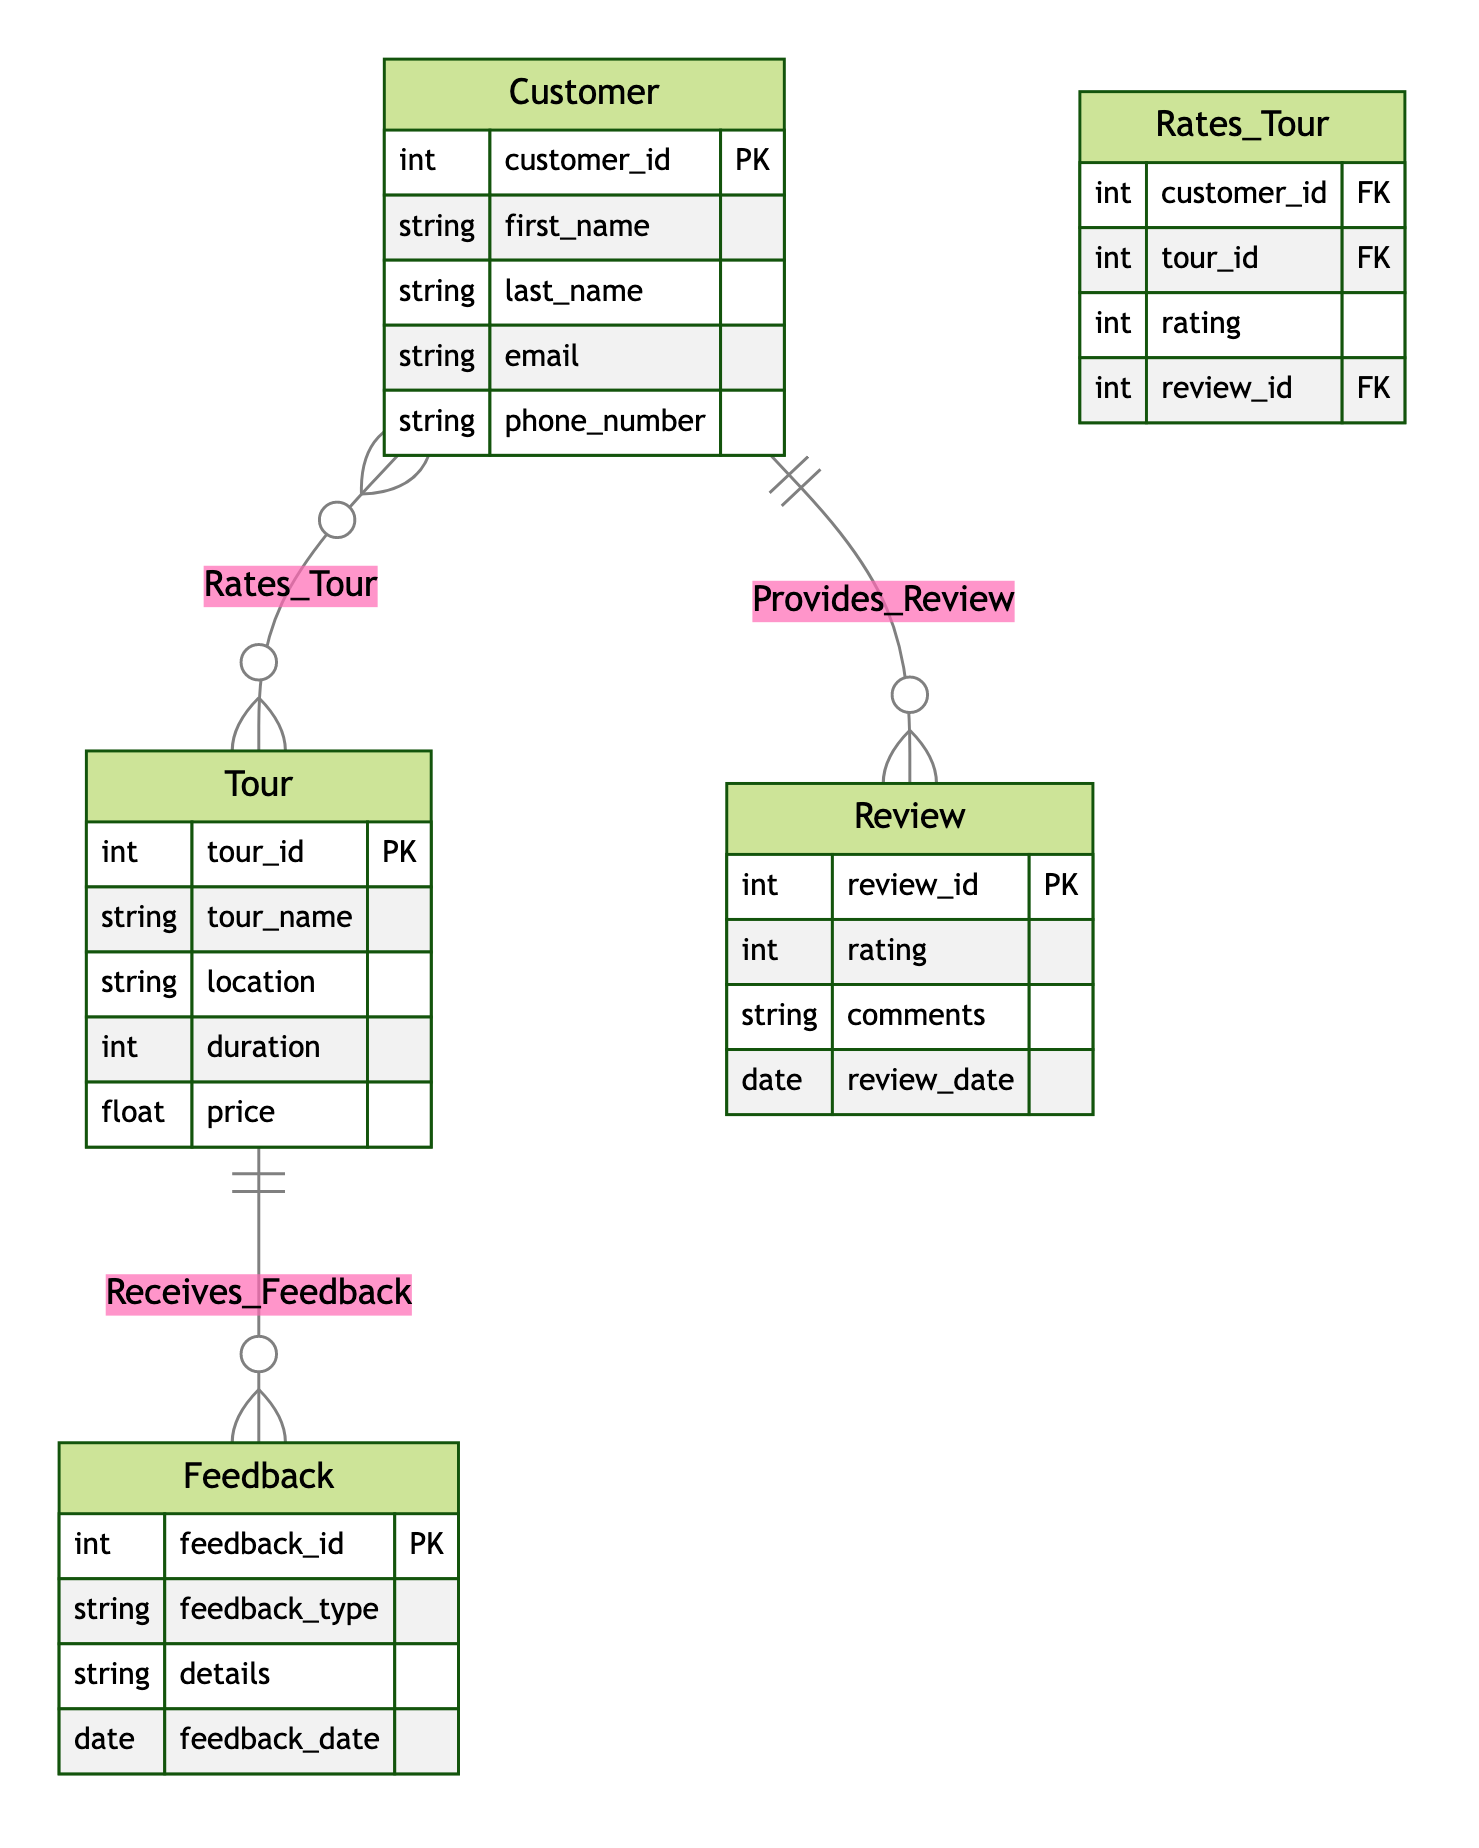What is the primary key of the Tour entity? The primary key for the Tour entity is "tour_id," which uniquely identifies each tour in the system.
Answer: tour_id How many entities are there in the diagram? The diagram includes four entities: Tour, Customer, Review, and Feedback. Therefore, by counting them, we find there are a total of four entities.
Answer: 4 What relationship connects Customer to Review? The relationship connecting Customer to Review is named "Provides_Review," indicating that customers provide reviews.
Answer: Provides_Review Which entity has the attribute "feedback_id"? The attribute "feedback_id" belongs to the Feedback entity, which uniquely identifies each piece of feedback given for the tours.
Answer: Feedback How many attributes does the Customer entity have? The Customer entity has five attributes: customer_id, first_name, last_name, email, and phone_number, which can be counted for verification.
Answer: 5 What relationship involves both rating and review_id? The relationship "Rates_Tour" includes the attributes rating and review_id, indicating that ratings and reviews are associated with the tours rated by customers.
Answer: Rates_Tour Which entity receives feedback? The entity that receives feedback is the Tour entity, demonstrating an interaction where feedback regarding tours is collected.
Answer: Tour What is the maximum rating value mentioned in the Review entity? The maximum typical rating value is often assumed to be 5, as it is standard for rating systems, though it should be confirmed in context.
Answer: 5 Which two entities are connected by the Receives_Feedback relationship? The Receives_Feedback relationship connects the Tour and Feedback entities, illustrating their interaction in the feedback system.
Answer: Tour and Feedback 